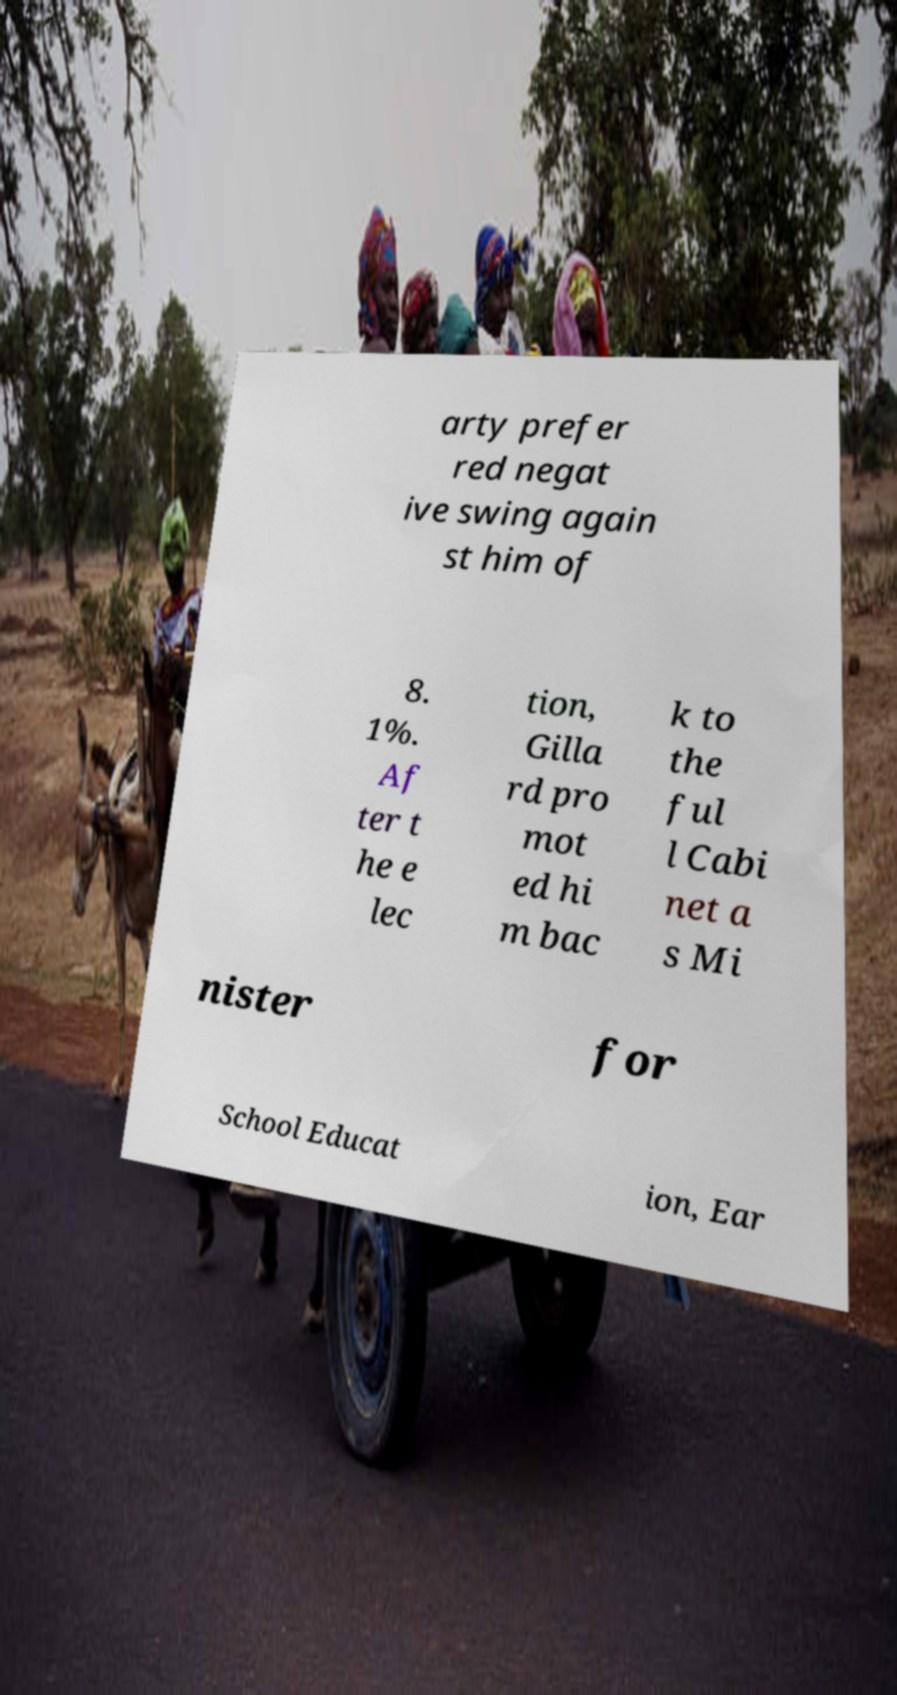Please identify and transcribe the text found in this image. arty prefer red negat ive swing again st him of 8. 1%. Af ter t he e lec tion, Gilla rd pro mot ed hi m bac k to the ful l Cabi net a s Mi nister for School Educat ion, Ear 